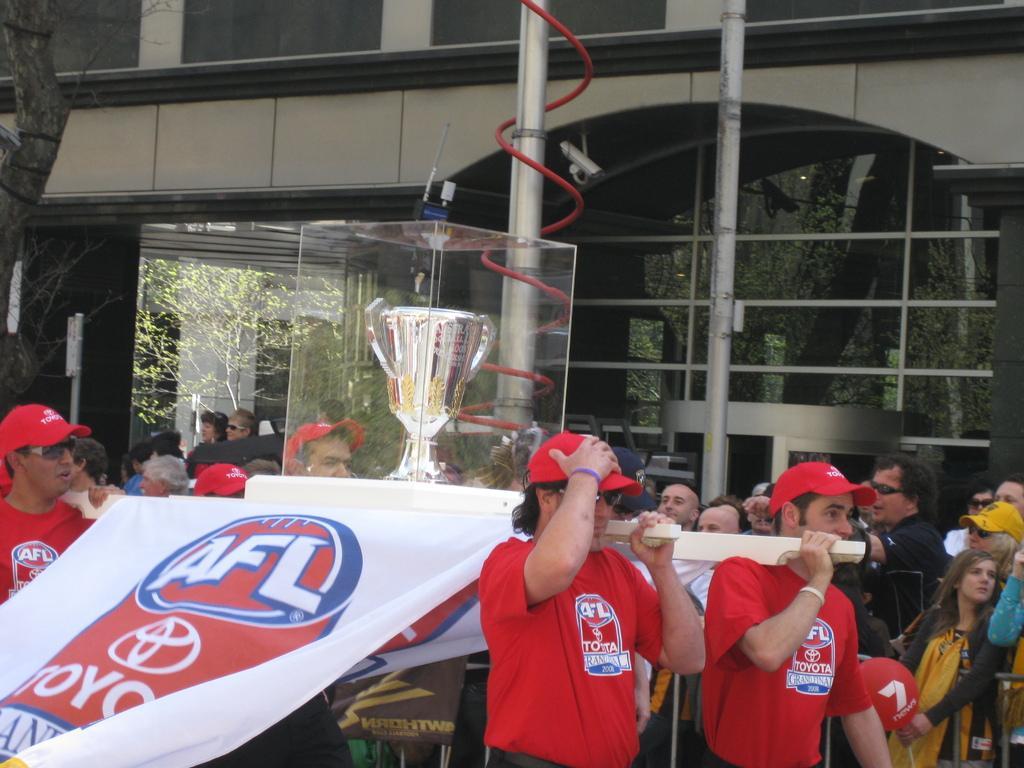Please provide a concise description of this image. In this image there are few people holding wooden sticks in their hands. On the sticks there is an award which is covered with glass frames and there is a banner with some text. In the background there are so many people standing and there are two poles, a tree and a building. 